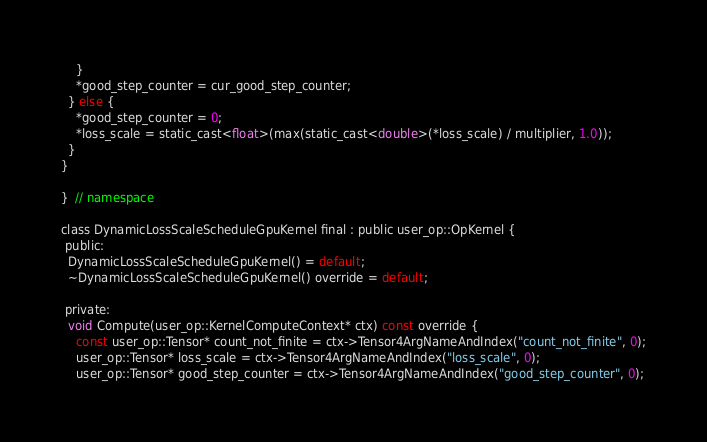<code> <loc_0><loc_0><loc_500><loc_500><_Cuda_>    }
    *good_step_counter = cur_good_step_counter;
  } else {
    *good_step_counter = 0;
    *loss_scale = static_cast<float>(max(static_cast<double>(*loss_scale) / multiplier, 1.0));
  }
}

}  // namespace

class DynamicLossScaleScheduleGpuKernel final : public user_op::OpKernel {
 public:
  DynamicLossScaleScheduleGpuKernel() = default;
  ~DynamicLossScaleScheduleGpuKernel() override = default;

 private:
  void Compute(user_op::KernelComputeContext* ctx) const override {
    const user_op::Tensor* count_not_finite = ctx->Tensor4ArgNameAndIndex("count_not_finite", 0);
    user_op::Tensor* loss_scale = ctx->Tensor4ArgNameAndIndex("loss_scale", 0);
    user_op::Tensor* good_step_counter = ctx->Tensor4ArgNameAndIndex("good_step_counter", 0);</code> 